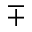Convert formula to latex. <formula><loc_0><loc_0><loc_500><loc_500>\mp</formula> 